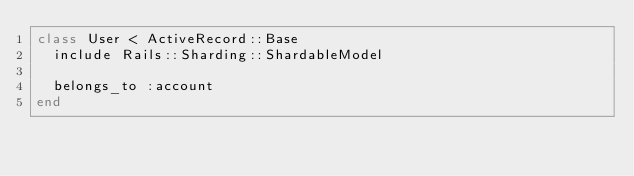Convert code to text. <code><loc_0><loc_0><loc_500><loc_500><_Ruby_>class User < ActiveRecord::Base
  include Rails::Sharding::ShardableModel

  belongs_to :account
end
</code> 